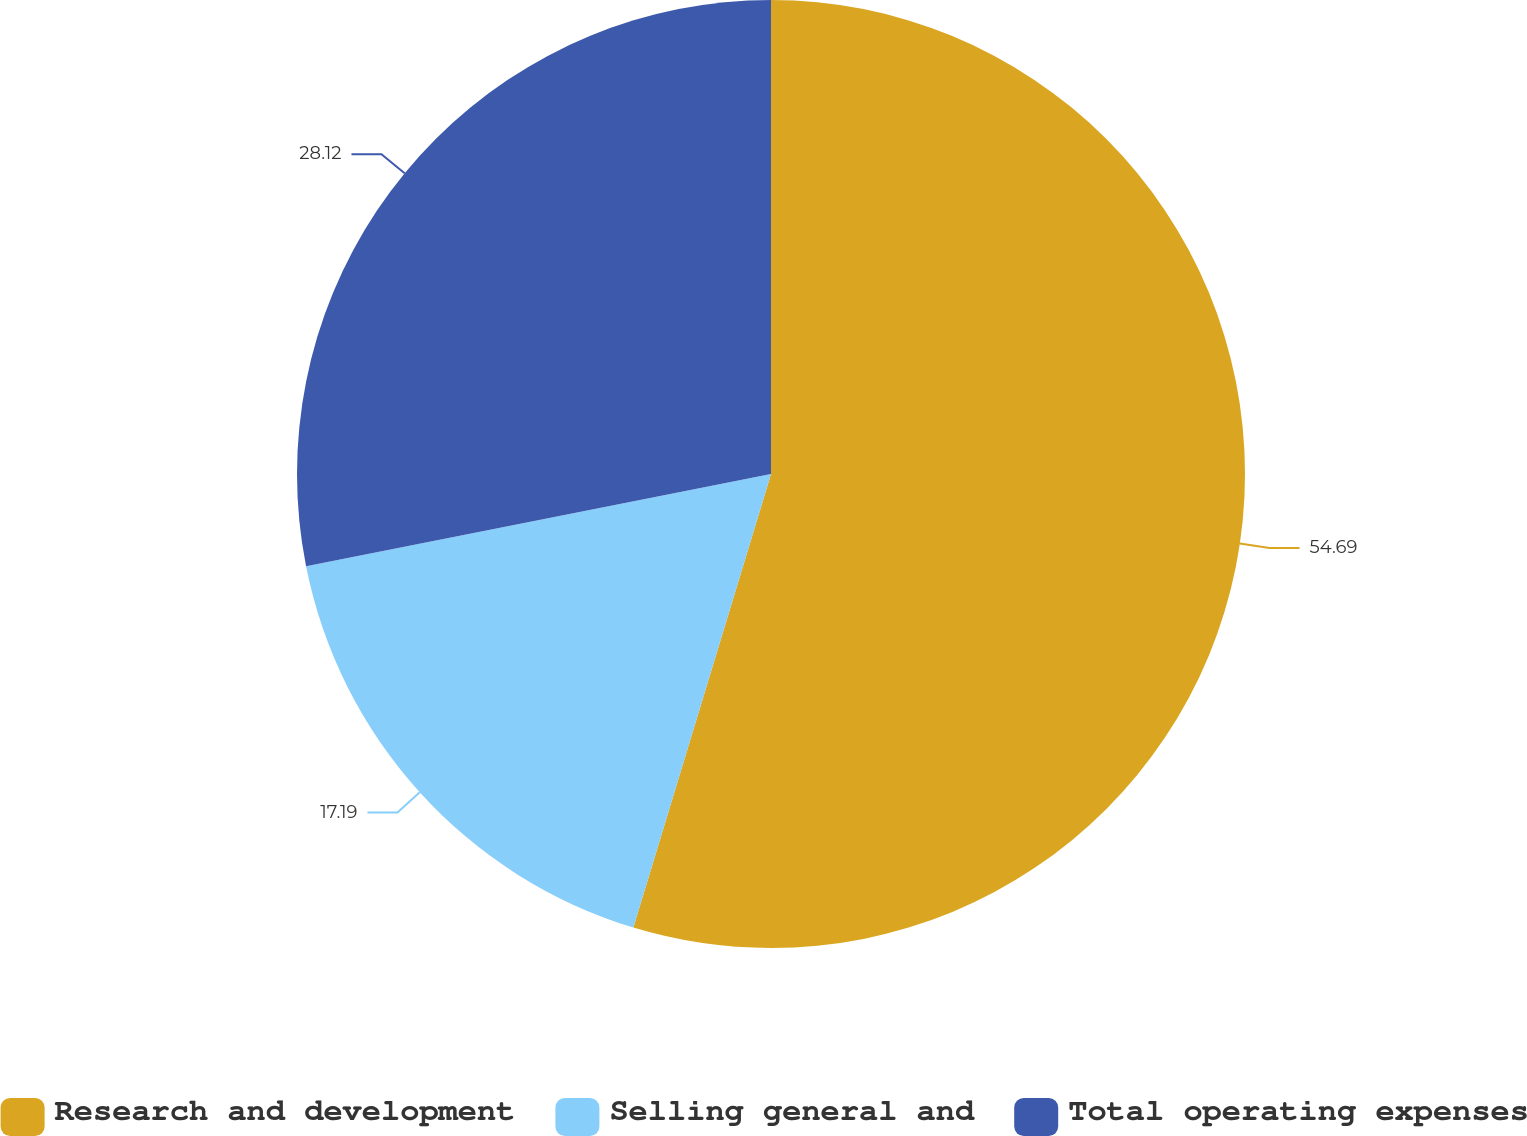<chart> <loc_0><loc_0><loc_500><loc_500><pie_chart><fcel>Research and development<fcel>Selling general and<fcel>Total operating expenses<nl><fcel>54.69%<fcel>17.19%<fcel>28.12%<nl></chart> 